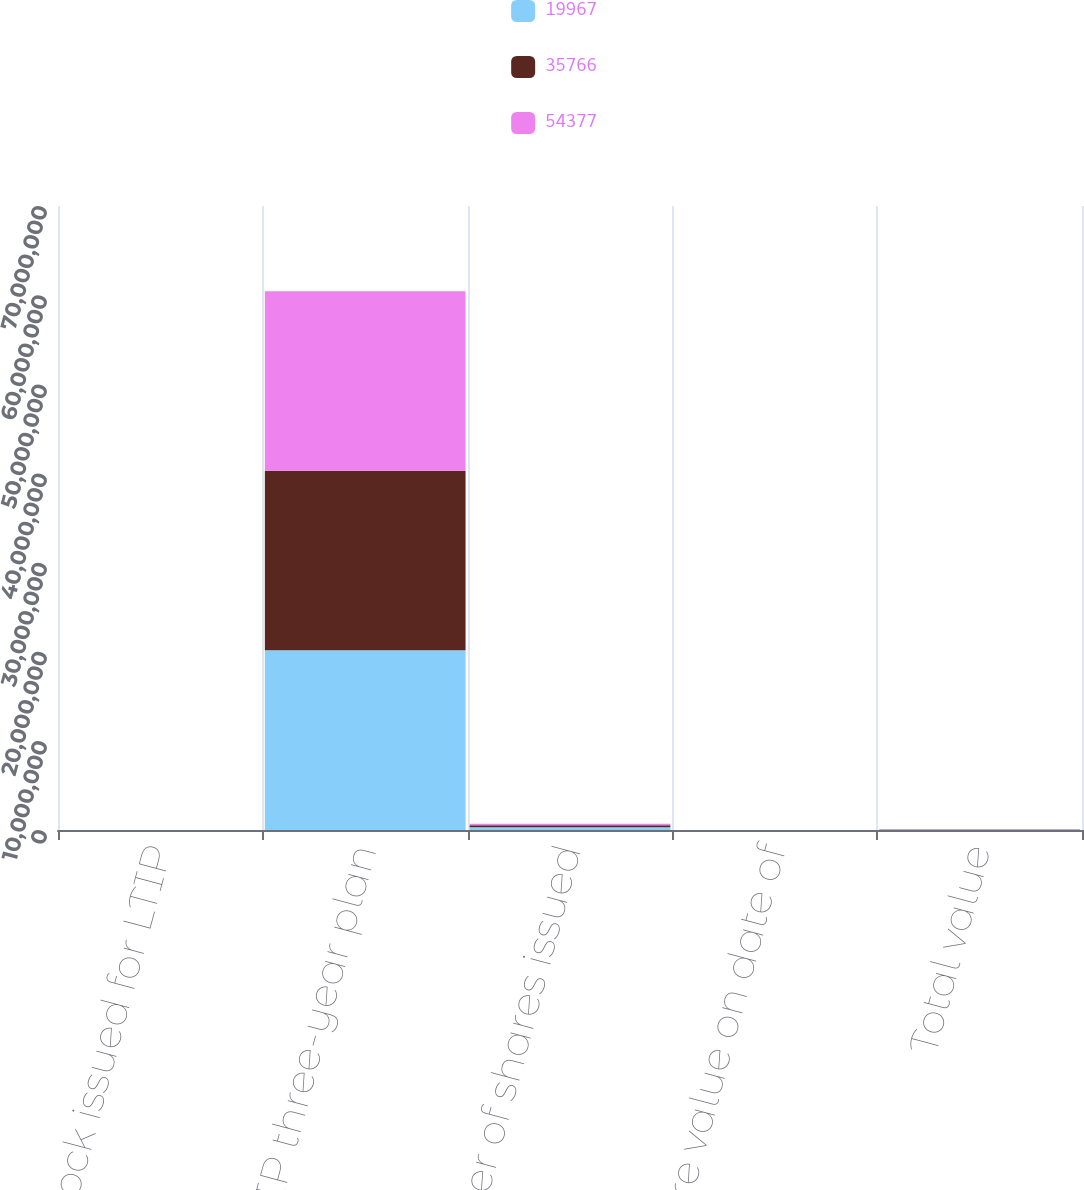Convert chart to OTSL. <chart><loc_0><loc_0><loc_500><loc_500><stacked_bar_chart><ecel><fcel>Stock issued for LTIP<fcel>LTIP three-year plan<fcel>Number of shares issued<fcel>Share value on date of<fcel>Total value<nl><fcel>19967<fcel>2018<fcel>2.01516e+07<fcel>308278<fcel>176.39<fcel>54377<nl><fcel>35766<fcel>2017<fcel>2.01415e+07<fcel>227707<fcel>157.07<fcel>35766<nl><fcel>54377<fcel>2016<fcel>2.01314e+07<fcel>175291<fcel>113.91<fcel>19967<nl></chart> 